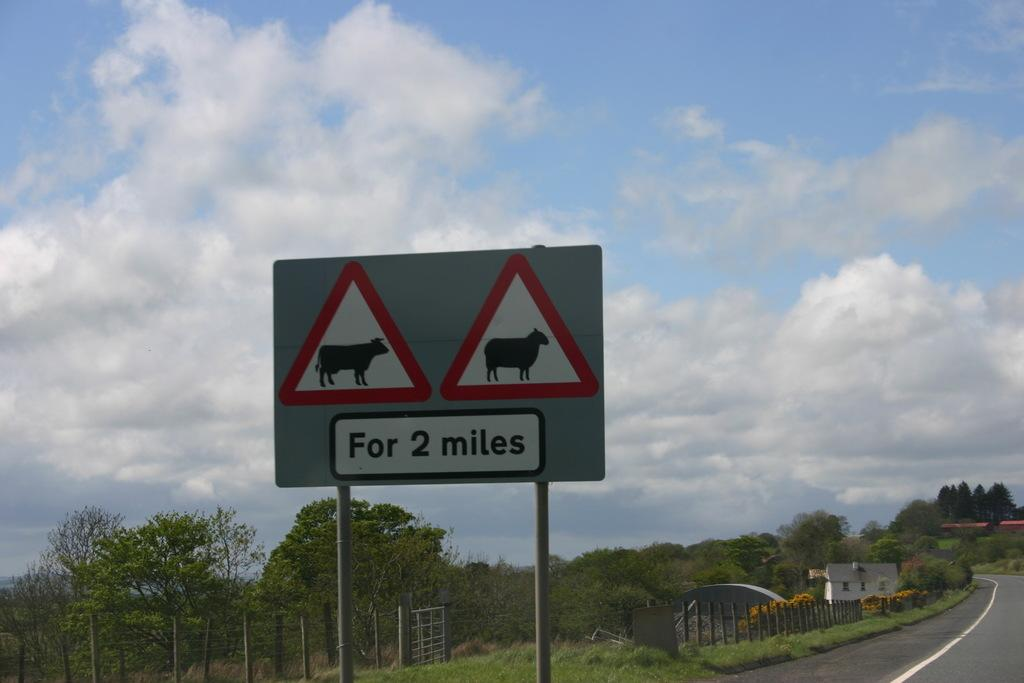<image>
Write a terse but informative summary of the picture. A road sign showing that there may be livestock on the road for the next two miles. 